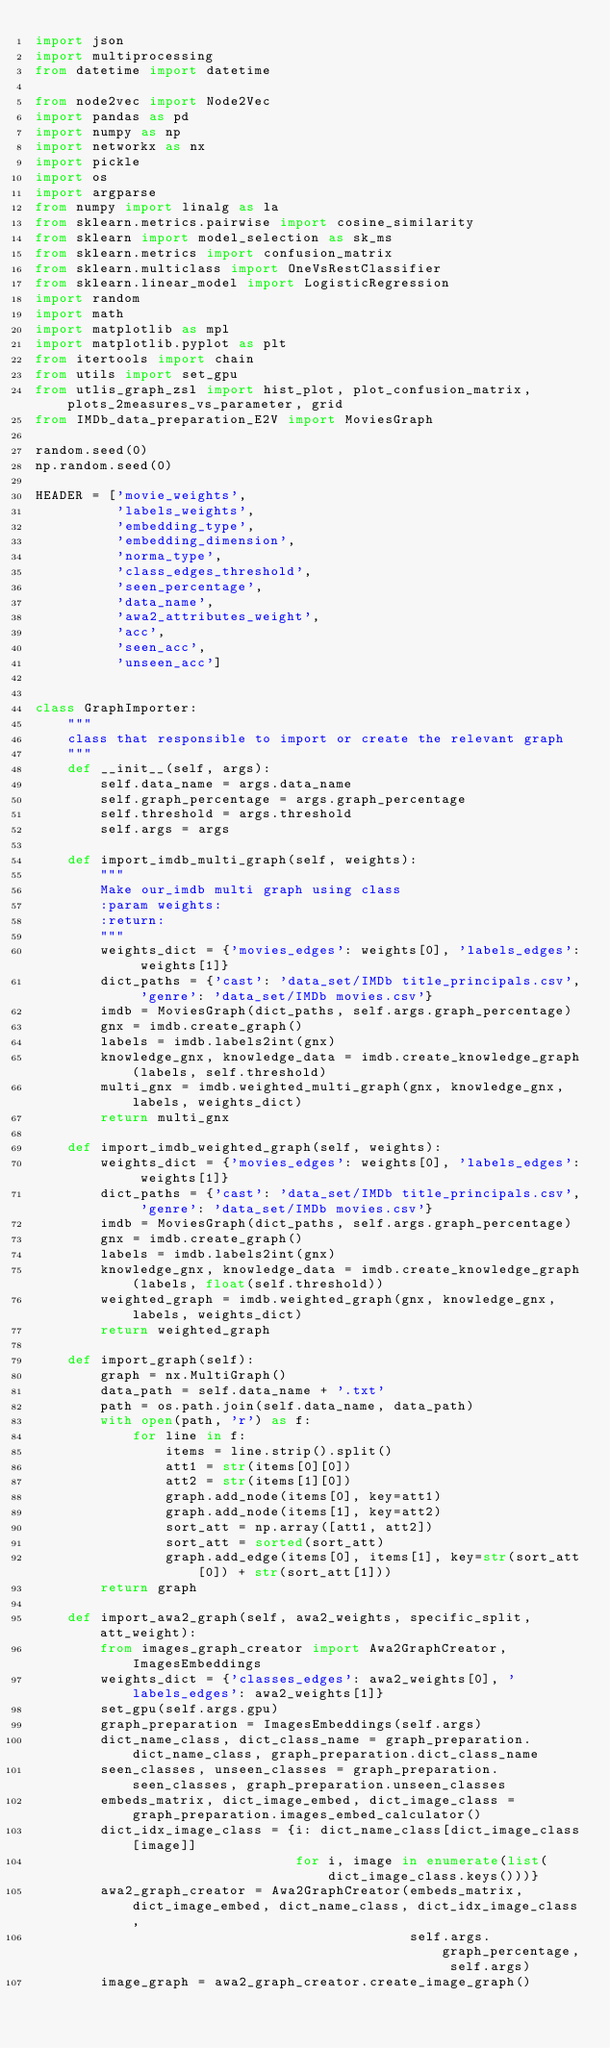Convert code to text. <code><loc_0><loc_0><loc_500><loc_500><_Python_>import json
import multiprocessing
from datetime import datetime

from node2vec import Node2Vec
import pandas as pd
import numpy as np
import networkx as nx
import pickle
import os
import argparse
from numpy import linalg as la
from sklearn.metrics.pairwise import cosine_similarity
from sklearn import model_selection as sk_ms
from sklearn.metrics import confusion_matrix
from sklearn.multiclass import OneVsRestClassifier
from sklearn.linear_model import LogisticRegression
import random
import math
import matplotlib as mpl
import matplotlib.pyplot as plt
from itertools import chain
from utils import set_gpu
from utlis_graph_zsl import hist_plot, plot_confusion_matrix, plots_2measures_vs_parameter, grid
from IMDb_data_preparation_E2V import MoviesGraph

random.seed(0)
np.random.seed(0)

HEADER = ['movie_weights',
          'labels_weights',
          'embedding_type',
          'embedding_dimension',
          'norma_type',
          'class_edges_threshold',
          'seen_percentage',
          'data_name',
          'awa2_attributes_weight',
          'acc',
          'seen_acc',
          'unseen_acc']


class GraphImporter:
    """
    class that responsible to import or create the relevant graph
    """
    def __init__(self, args):
        self.data_name = args.data_name
        self.graph_percentage = args.graph_percentage
        self.threshold = args.threshold
        self.args = args

    def import_imdb_multi_graph(self, weights):
        """
        Make our_imdb multi graph using class
        :param weights:
        :return:
        """
        weights_dict = {'movies_edges': weights[0], 'labels_edges': weights[1]}
        dict_paths = {'cast': 'data_set/IMDb title_principals.csv', 'genre': 'data_set/IMDb movies.csv'}
        imdb = MoviesGraph(dict_paths, self.args.graph_percentage)
        gnx = imdb.create_graph()
        labels = imdb.labels2int(gnx)
        knowledge_gnx, knowledge_data = imdb.create_knowledge_graph(labels, self.threshold)
        multi_gnx = imdb.weighted_multi_graph(gnx, knowledge_gnx, labels, weights_dict)
        return multi_gnx

    def import_imdb_weighted_graph(self, weights):
        weights_dict = {'movies_edges': weights[0], 'labels_edges': weights[1]}
        dict_paths = {'cast': 'data_set/IMDb title_principals.csv', 'genre': 'data_set/IMDb movies.csv'}
        imdb = MoviesGraph(dict_paths, self.args.graph_percentage)
        gnx = imdb.create_graph()
        labels = imdb.labels2int(gnx)
        knowledge_gnx, knowledge_data = imdb.create_knowledge_graph(labels, float(self.threshold))
        weighted_graph = imdb.weighted_graph(gnx, knowledge_gnx, labels, weights_dict)
        return weighted_graph

    def import_graph(self):
        graph = nx.MultiGraph()
        data_path = self.data_name + '.txt'
        path = os.path.join(self.data_name, data_path)
        with open(path, 'r') as f:
            for line in f:
                items = line.strip().split()
                att1 = str(items[0][0])
                att2 = str(items[1][0])
                graph.add_node(items[0], key=att1)
                graph.add_node(items[1], key=att2)
                sort_att = np.array([att1, att2])
                sort_att = sorted(sort_att)
                graph.add_edge(items[0], items[1], key=str(sort_att[0]) + str(sort_att[1]))
        return graph

    def import_awa2_graph(self, awa2_weights, specific_split, att_weight):
        from images_graph_creator import Awa2GraphCreator, ImagesEmbeddings
        weights_dict = {'classes_edges': awa2_weights[0], 'labels_edges': awa2_weights[1]}
        set_gpu(self.args.gpu)
        graph_preparation = ImagesEmbeddings(self.args)
        dict_name_class, dict_class_name = graph_preparation.dict_name_class, graph_preparation.dict_class_name
        seen_classes, unseen_classes = graph_preparation.seen_classes, graph_preparation.unseen_classes
        embeds_matrix, dict_image_embed, dict_image_class = graph_preparation.images_embed_calculator()
        dict_idx_image_class = {i: dict_name_class[dict_image_class[image]]
                                for i, image in enumerate(list(dict_image_class.keys()))}
        awa2_graph_creator = Awa2GraphCreator(embeds_matrix, dict_image_embed, dict_name_class, dict_idx_image_class,
                                              self.args.graph_percentage, self.args)
        image_graph = awa2_graph_creator.create_image_graph()</code> 